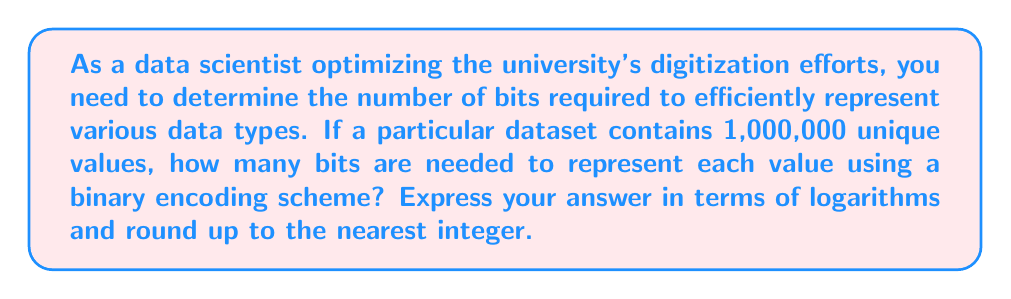What is the answer to this math problem? To solve this problem, we need to use the concept of information theory and logarithms. The number of bits required to represent a certain number of unique values is given by the logarithm base 2 of the number of values, rounded up to the nearest integer.

Let's break it down step-by-step:

1. We have 1,000,000 unique values to represent.

2. The formula to calculate the number of bits is:

   $$\text{bits} = \lceil \log_2(n) \rceil$$

   Where $n$ is the number of unique values, and $\lceil \cdot \rceil$ represents the ceiling function (rounding up to the nearest integer).

3. Substituting our value:

   $$\text{bits} = \lceil \log_2(1,000,000) \rceil$$

4. We can simplify this using the properties of logarithms:

   $$\begin{align}
   \log_2(1,000,000) &= \log_2(10^6) \\
   &= 6 \log_2(10) \\
   &\approx 6 \times 3.32192809 \\
   &\approx 19.9315685
   \end{align}$$

5. Rounding up to the nearest integer:

   $$\lceil 19.9315685 \rceil = 20$$

Therefore, 20 bits are required to represent each value in the dataset.
Answer: 20 bits 